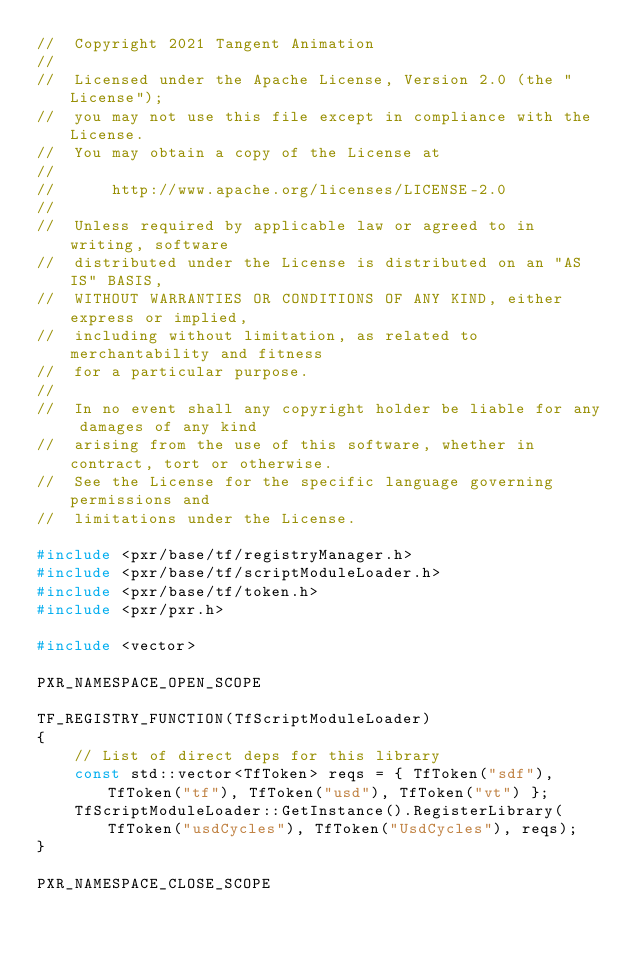<code> <loc_0><loc_0><loc_500><loc_500><_C++_>//  Copyright 2021 Tangent Animation
//
//  Licensed under the Apache License, Version 2.0 (the "License");
//  you may not use this file except in compliance with the License.
//  You may obtain a copy of the License at
//
//      http://www.apache.org/licenses/LICENSE-2.0
//
//  Unless required by applicable law or agreed to in writing, software
//  distributed under the License is distributed on an "AS IS" BASIS,
//  WITHOUT WARRANTIES OR CONDITIONS OF ANY KIND, either express or implied,
//  including without limitation, as related to merchantability and fitness
//  for a particular purpose.
//
//  In no event shall any copyright holder be liable for any damages of any kind
//  arising from the use of this software, whether in contract, tort or otherwise.
//  See the License for the specific language governing permissions and
//  limitations under the License.

#include <pxr/base/tf/registryManager.h>
#include <pxr/base/tf/scriptModuleLoader.h>
#include <pxr/base/tf/token.h>
#include <pxr/pxr.h>

#include <vector>

PXR_NAMESPACE_OPEN_SCOPE

TF_REGISTRY_FUNCTION(TfScriptModuleLoader)
{
    // List of direct deps for this library
    const std::vector<TfToken> reqs = { TfToken("sdf"), TfToken("tf"), TfToken("usd"), TfToken("vt") };
    TfScriptModuleLoader::GetInstance().RegisterLibrary(TfToken("usdCycles"), TfToken("UsdCycles"), reqs);
}

PXR_NAMESPACE_CLOSE_SCOPE</code> 